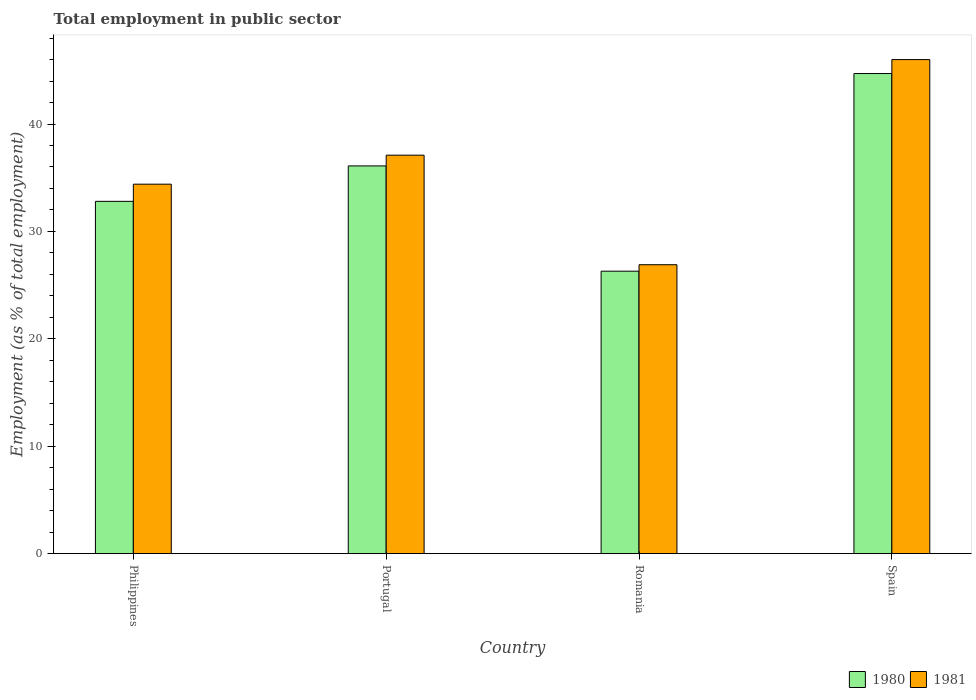Are the number of bars on each tick of the X-axis equal?
Offer a very short reply. Yes. How many bars are there on the 2nd tick from the right?
Offer a terse response. 2. What is the label of the 1st group of bars from the left?
Make the answer very short. Philippines. What is the employment in public sector in 1981 in Portugal?
Your answer should be very brief. 37.1. Across all countries, what is the maximum employment in public sector in 1980?
Make the answer very short. 44.7. Across all countries, what is the minimum employment in public sector in 1980?
Ensure brevity in your answer.  26.3. In which country was the employment in public sector in 1981 minimum?
Keep it short and to the point. Romania. What is the total employment in public sector in 1980 in the graph?
Ensure brevity in your answer.  139.9. What is the difference between the employment in public sector in 1981 in Philippines and that in Portugal?
Your response must be concise. -2.7. What is the difference between the employment in public sector in 1980 in Romania and the employment in public sector in 1981 in Philippines?
Offer a terse response. -8.1. What is the average employment in public sector in 1980 per country?
Provide a short and direct response. 34.97. What is the difference between the employment in public sector of/in 1980 and employment in public sector of/in 1981 in Spain?
Offer a terse response. -1.3. What is the ratio of the employment in public sector in 1980 in Philippines to that in Romania?
Your answer should be compact. 1.25. Is the difference between the employment in public sector in 1980 in Philippines and Romania greater than the difference between the employment in public sector in 1981 in Philippines and Romania?
Provide a short and direct response. No. What is the difference between the highest and the second highest employment in public sector in 1981?
Offer a very short reply. -2.7. What is the difference between the highest and the lowest employment in public sector in 1981?
Your answer should be compact. 19.1. Is the sum of the employment in public sector in 1981 in Philippines and Portugal greater than the maximum employment in public sector in 1980 across all countries?
Your answer should be compact. Yes. What does the 1st bar from the left in Romania represents?
Offer a terse response. 1980. How many bars are there?
Ensure brevity in your answer.  8. Are all the bars in the graph horizontal?
Offer a very short reply. No. What is the difference between two consecutive major ticks on the Y-axis?
Keep it short and to the point. 10. Are the values on the major ticks of Y-axis written in scientific E-notation?
Offer a very short reply. No. Does the graph contain any zero values?
Your response must be concise. No. Does the graph contain grids?
Your response must be concise. No. What is the title of the graph?
Provide a succinct answer. Total employment in public sector. Does "1973" appear as one of the legend labels in the graph?
Make the answer very short. No. What is the label or title of the X-axis?
Give a very brief answer. Country. What is the label or title of the Y-axis?
Offer a very short reply. Employment (as % of total employment). What is the Employment (as % of total employment) in 1980 in Philippines?
Make the answer very short. 32.8. What is the Employment (as % of total employment) of 1981 in Philippines?
Offer a terse response. 34.4. What is the Employment (as % of total employment) of 1980 in Portugal?
Offer a very short reply. 36.1. What is the Employment (as % of total employment) in 1981 in Portugal?
Provide a short and direct response. 37.1. What is the Employment (as % of total employment) in 1980 in Romania?
Provide a short and direct response. 26.3. What is the Employment (as % of total employment) in 1981 in Romania?
Your answer should be very brief. 26.9. What is the Employment (as % of total employment) in 1980 in Spain?
Your answer should be very brief. 44.7. What is the Employment (as % of total employment) in 1981 in Spain?
Make the answer very short. 46. Across all countries, what is the maximum Employment (as % of total employment) of 1980?
Your response must be concise. 44.7. Across all countries, what is the maximum Employment (as % of total employment) in 1981?
Ensure brevity in your answer.  46. Across all countries, what is the minimum Employment (as % of total employment) in 1980?
Offer a very short reply. 26.3. Across all countries, what is the minimum Employment (as % of total employment) of 1981?
Your answer should be very brief. 26.9. What is the total Employment (as % of total employment) in 1980 in the graph?
Your answer should be compact. 139.9. What is the total Employment (as % of total employment) in 1981 in the graph?
Provide a succinct answer. 144.4. What is the difference between the Employment (as % of total employment) of 1981 in Philippines and that in Portugal?
Make the answer very short. -2.7. What is the difference between the Employment (as % of total employment) in 1980 in Philippines and that in Romania?
Provide a short and direct response. 6.5. What is the difference between the Employment (as % of total employment) of 1980 in Philippines and that in Spain?
Make the answer very short. -11.9. What is the difference between the Employment (as % of total employment) in 1981 in Philippines and that in Spain?
Make the answer very short. -11.6. What is the difference between the Employment (as % of total employment) of 1981 in Portugal and that in Romania?
Provide a succinct answer. 10.2. What is the difference between the Employment (as % of total employment) in 1980 in Portugal and that in Spain?
Make the answer very short. -8.6. What is the difference between the Employment (as % of total employment) of 1981 in Portugal and that in Spain?
Offer a terse response. -8.9. What is the difference between the Employment (as % of total employment) in 1980 in Romania and that in Spain?
Make the answer very short. -18.4. What is the difference between the Employment (as % of total employment) of 1981 in Romania and that in Spain?
Offer a terse response. -19.1. What is the difference between the Employment (as % of total employment) in 1980 in Philippines and the Employment (as % of total employment) in 1981 in Romania?
Ensure brevity in your answer.  5.9. What is the difference between the Employment (as % of total employment) of 1980 in Portugal and the Employment (as % of total employment) of 1981 in Romania?
Your answer should be compact. 9.2. What is the difference between the Employment (as % of total employment) in 1980 in Portugal and the Employment (as % of total employment) in 1981 in Spain?
Your answer should be compact. -9.9. What is the difference between the Employment (as % of total employment) in 1980 in Romania and the Employment (as % of total employment) in 1981 in Spain?
Make the answer very short. -19.7. What is the average Employment (as % of total employment) of 1980 per country?
Your response must be concise. 34.98. What is the average Employment (as % of total employment) of 1981 per country?
Provide a succinct answer. 36.1. What is the difference between the Employment (as % of total employment) in 1980 and Employment (as % of total employment) in 1981 in Philippines?
Give a very brief answer. -1.6. What is the difference between the Employment (as % of total employment) in 1980 and Employment (as % of total employment) in 1981 in Romania?
Your response must be concise. -0.6. What is the difference between the Employment (as % of total employment) in 1980 and Employment (as % of total employment) in 1981 in Spain?
Your response must be concise. -1.3. What is the ratio of the Employment (as % of total employment) of 1980 in Philippines to that in Portugal?
Ensure brevity in your answer.  0.91. What is the ratio of the Employment (as % of total employment) in 1981 in Philippines to that in Portugal?
Provide a succinct answer. 0.93. What is the ratio of the Employment (as % of total employment) in 1980 in Philippines to that in Romania?
Your answer should be very brief. 1.25. What is the ratio of the Employment (as % of total employment) in 1981 in Philippines to that in Romania?
Keep it short and to the point. 1.28. What is the ratio of the Employment (as % of total employment) of 1980 in Philippines to that in Spain?
Offer a terse response. 0.73. What is the ratio of the Employment (as % of total employment) in 1981 in Philippines to that in Spain?
Make the answer very short. 0.75. What is the ratio of the Employment (as % of total employment) of 1980 in Portugal to that in Romania?
Your answer should be compact. 1.37. What is the ratio of the Employment (as % of total employment) in 1981 in Portugal to that in Romania?
Keep it short and to the point. 1.38. What is the ratio of the Employment (as % of total employment) in 1980 in Portugal to that in Spain?
Provide a short and direct response. 0.81. What is the ratio of the Employment (as % of total employment) in 1981 in Portugal to that in Spain?
Keep it short and to the point. 0.81. What is the ratio of the Employment (as % of total employment) in 1980 in Romania to that in Spain?
Your answer should be compact. 0.59. What is the ratio of the Employment (as % of total employment) in 1981 in Romania to that in Spain?
Provide a succinct answer. 0.58. What is the difference between the highest and the second highest Employment (as % of total employment) in 1980?
Your response must be concise. 8.6. What is the difference between the highest and the lowest Employment (as % of total employment) of 1981?
Offer a very short reply. 19.1. 